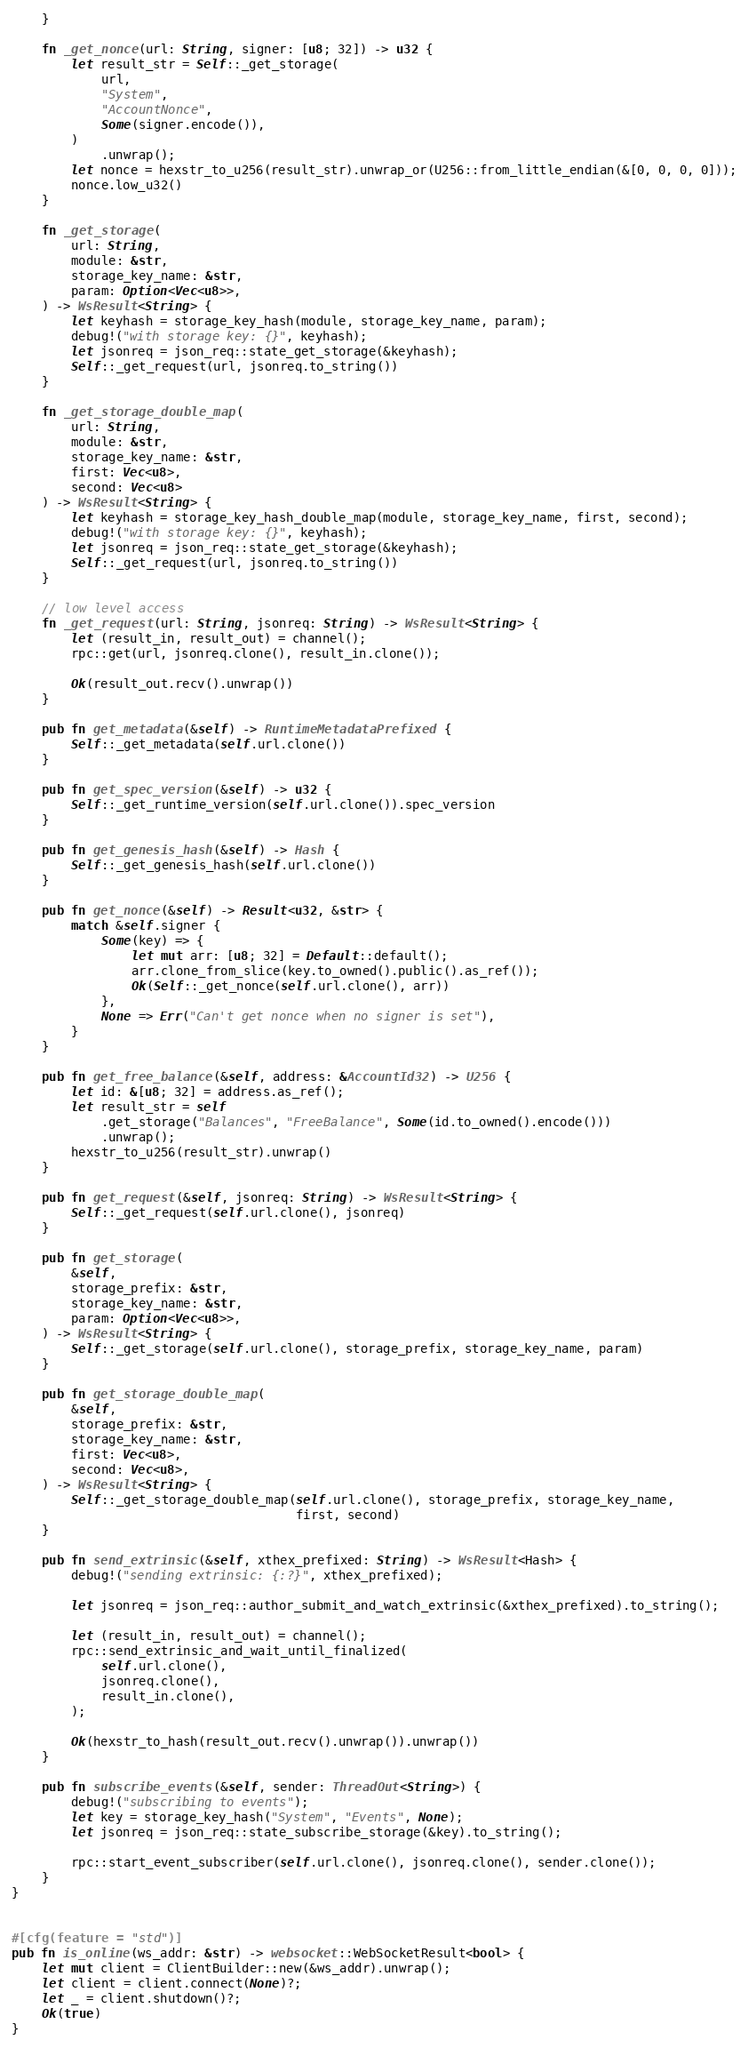<code> <loc_0><loc_0><loc_500><loc_500><_Rust_>    }

    fn _get_nonce(url: String, signer: [u8; 32]) -> u32 {
        let result_str = Self::_get_storage(
            url,
            "System",
            "AccountNonce",
            Some(signer.encode()),
        )
            .unwrap();
        let nonce = hexstr_to_u256(result_str).unwrap_or(U256::from_little_endian(&[0, 0, 0, 0]));
        nonce.low_u32()
    }

    fn _get_storage(
        url: String,
        module: &str,
        storage_key_name: &str,
        param: Option<Vec<u8>>,
    ) -> WsResult<String> {
        let keyhash = storage_key_hash(module, storage_key_name, param);
        debug!("with storage key: {}", keyhash);
        let jsonreq = json_req::state_get_storage(&keyhash);
        Self::_get_request(url, jsonreq.to_string())
    }

    fn _get_storage_double_map(
        url: String,
        module: &str,
        storage_key_name: &str,
        first: Vec<u8>,
        second: Vec<u8>
    ) -> WsResult<String> {
        let keyhash = storage_key_hash_double_map(module, storage_key_name, first, second);
        debug!("with storage key: {}", keyhash);
        let jsonreq = json_req::state_get_storage(&keyhash);
        Self::_get_request(url, jsonreq.to_string())
    }

    // low level access
    fn _get_request(url: String, jsonreq: String) -> WsResult<String> {
        let (result_in, result_out) = channel();
        rpc::get(url, jsonreq.clone(), result_in.clone());

        Ok(result_out.recv().unwrap())
    }

    pub fn get_metadata(&self) -> RuntimeMetadataPrefixed {
        Self::_get_metadata(self.url.clone())
    }

    pub fn get_spec_version(&self) -> u32 {
        Self::_get_runtime_version(self.url.clone()).spec_version
    }

    pub fn get_genesis_hash(&self) -> Hash {
        Self::_get_genesis_hash(self.url.clone())
    }

    pub fn get_nonce(&self) -> Result<u32, &str> {
        match &self.signer {
            Some(key) => {
                let mut arr: [u8; 32] = Default::default();
                arr.clone_from_slice(key.to_owned().public().as_ref());
                Ok(Self::_get_nonce(self.url.clone(), arr))
            },
            None => Err("Can't get nonce when no signer is set"),
        }
    }

    pub fn get_free_balance(&self, address: &AccountId32) -> U256 {
        let id: &[u8; 32] = address.as_ref();
        let result_str = self
            .get_storage("Balances", "FreeBalance", Some(id.to_owned().encode()))
            .unwrap();
        hexstr_to_u256(result_str).unwrap()
    }

    pub fn get_request(&self, jsonreq: String) -> WsResult<String> {
        Self::_get_request(self.url.clone(), jsonreq)
    }

    pub fn get_storage(
        &self,
        storage_prefix: &str,
        storage_key_name: &str,
        param: Option<Vec<u8>>,
    ) -> WsResult<String> {
        Self::_get_storage(self.url.clone(), storage_prefix, storage_key_name, param)
    }

    pub fn get_storage_double_map(
        &self,
        storage_prefix: &str,
        storage_key_name: &str,
        first: Vec<u8>,
        second: Vec<u8>,
    ) -> WsResult<String> {
        Self::_get_storage_double_map(self.url.clone(), storage_prefix, storage_key_name,
                                      first, second)
    }

    pub fn send_extrinsic(&self, xthex_prefixed: String) -> WsResult<Hash> {
        debug!("sending extrinsic: {:?}", xthex_prefixed);

        let jsonreq = json_req::author_submit_and_watch_extrinsic(&xthex_prefixed).to_string();

        let (result_in, result_out) = channel();
        rpc::send_extrinsic_and_wait_until_finalized(
            self.url.clone(),
            jsonreq.clone(),
            result_in.clone(),
        );

        Ok(hexstr_to_hash(result_out.recv().unwrap()).unwrap())
    }

    pub fn subscribe_events(&self, sender: ThreadOut<String>) {
        debug!("subscribing to events");
        let key = storage_key_hash("System", "Events", None);
        let jsonreq = json_req::state_subscribe_storage(&key).to_string();

        rpc::start_event_subscriber(self.url.clone(), jsonreq.clone(), sender.clone());
    }
}


#[cfg(feature = "std")]
pub fn is_online(ws_addr: &str) -> websocket::WebSocketResult<bool> {
    let mut client = ClientBuilder::new(&ws_addr).unwrap();
    let client = client.connect(None)?;
    let _ = client.shutdown()?;
    Ok(true)
}
</code> 